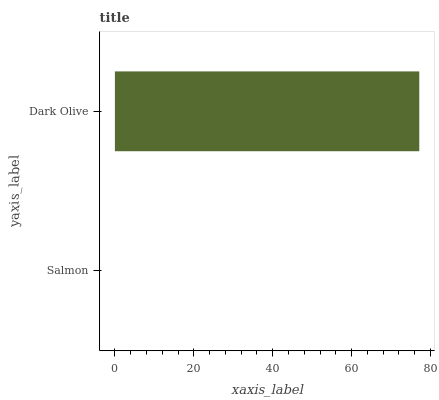Is Salmon the minimum?
Answer yes or no. Yes. Is Dark Olive the maximum?
Answer yes or no. Yes. Is Dark Olive the minimum?
Answer yes or no. No. Is Dark Olive greater than Salmon?
Answer yes or no. Yes. Is Salmon less than Dark Olive?
Answer yes or no. Yes. Is Salmon greater than Dark Olive?
Answer yes or no. No. Is Dark Olive less than Salmon?
Answer yes or no. No. Is Dark Olive the high median?
Answer yes or no. Yes. Is Salmon the low median?
Answer yes or no. Yes. Is Salmon the high median?
Answer yes or no. No. Is Dark Olive the low median?
Answer yes or no. No. 